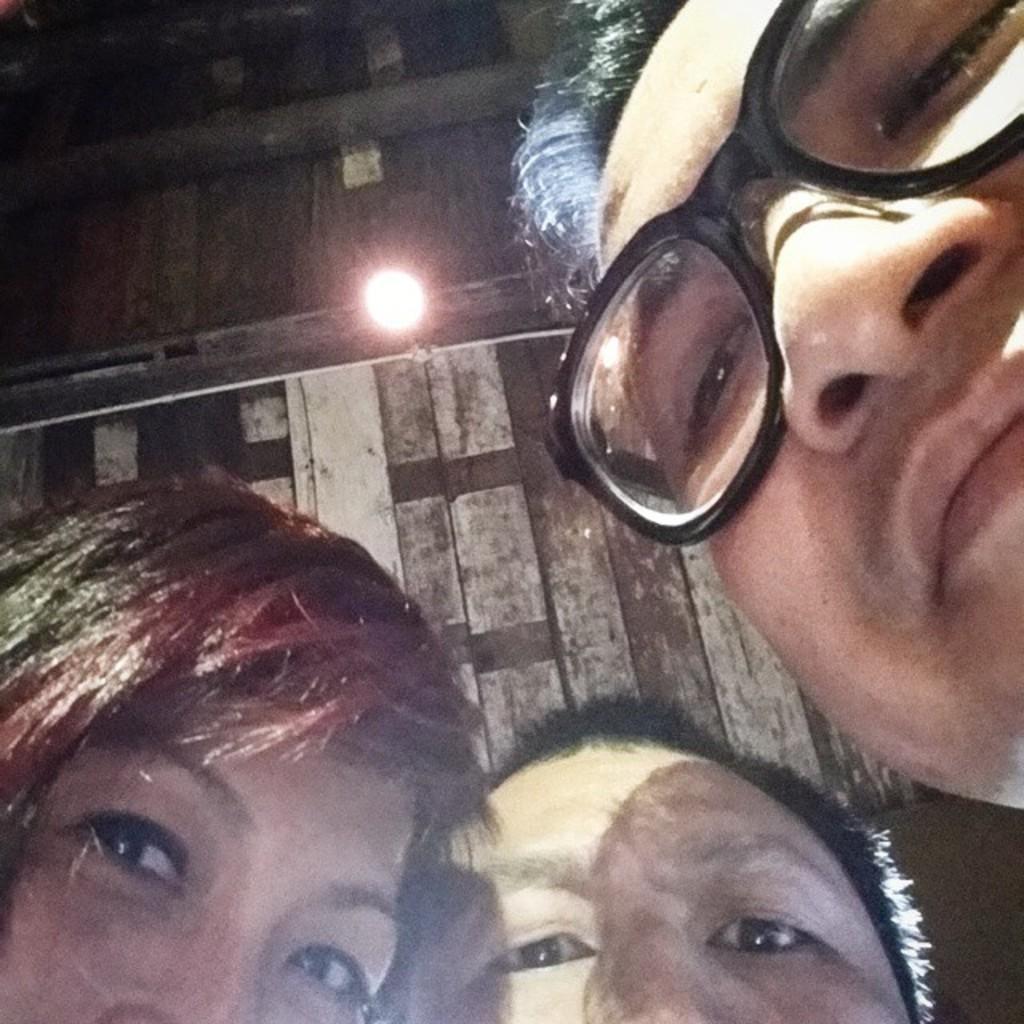Could you give a brief overview of what you see in this image? In this image we can see three people. Above the people we can see wall and an electric light. 